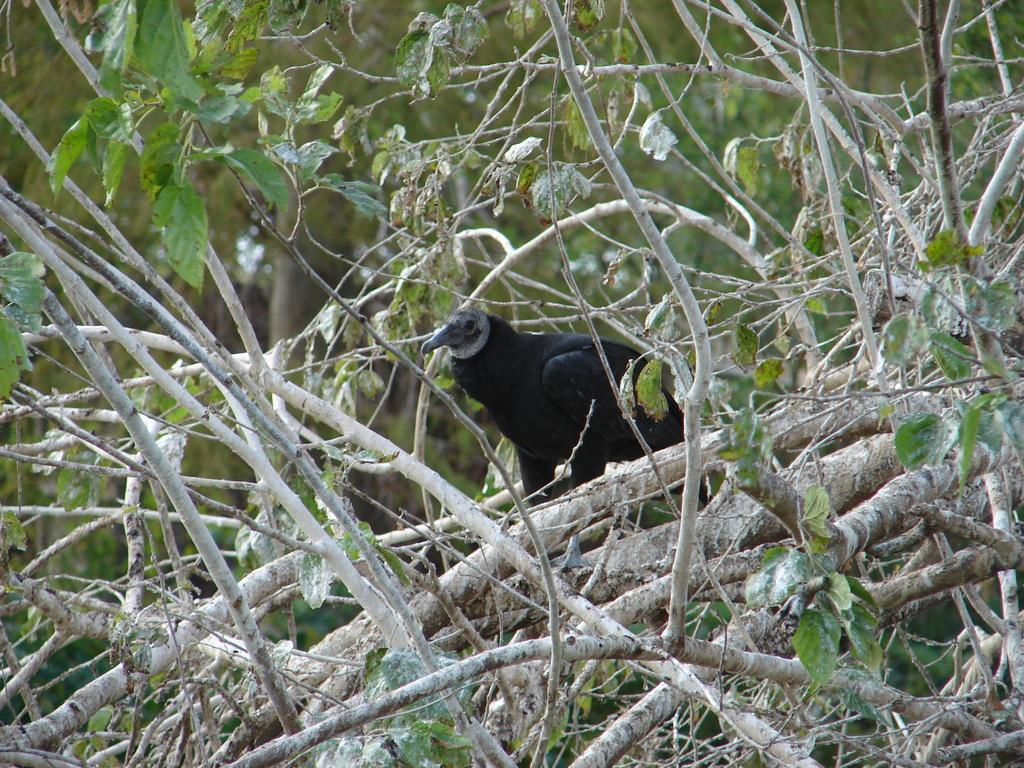What is the main subject in the middle of the picture? There is a bird in the middle of the picture. What color is the bird? The bird is black in color. What can be seen in the background of the picture? There are trees visible in the picture. What is the price of the crown worn by the bird in the picture? There is no crown present in the image, and therefore no price can be determined. 